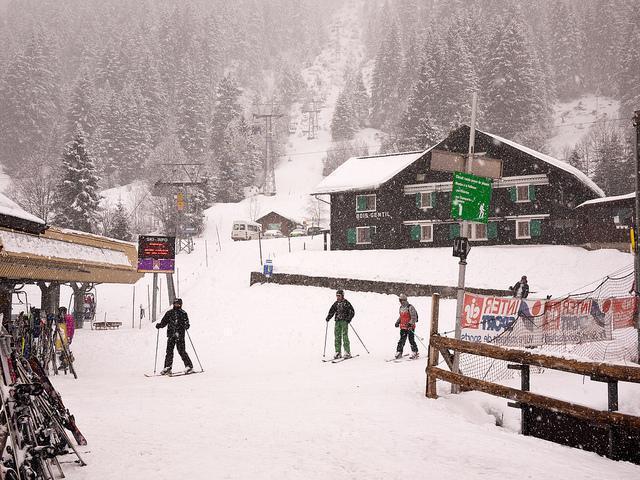What kind of stand is shown?
Indicate the correct response by choosing from the four available options to answer the question.
Options: Rental, lunch, produce, drink. Rental. 